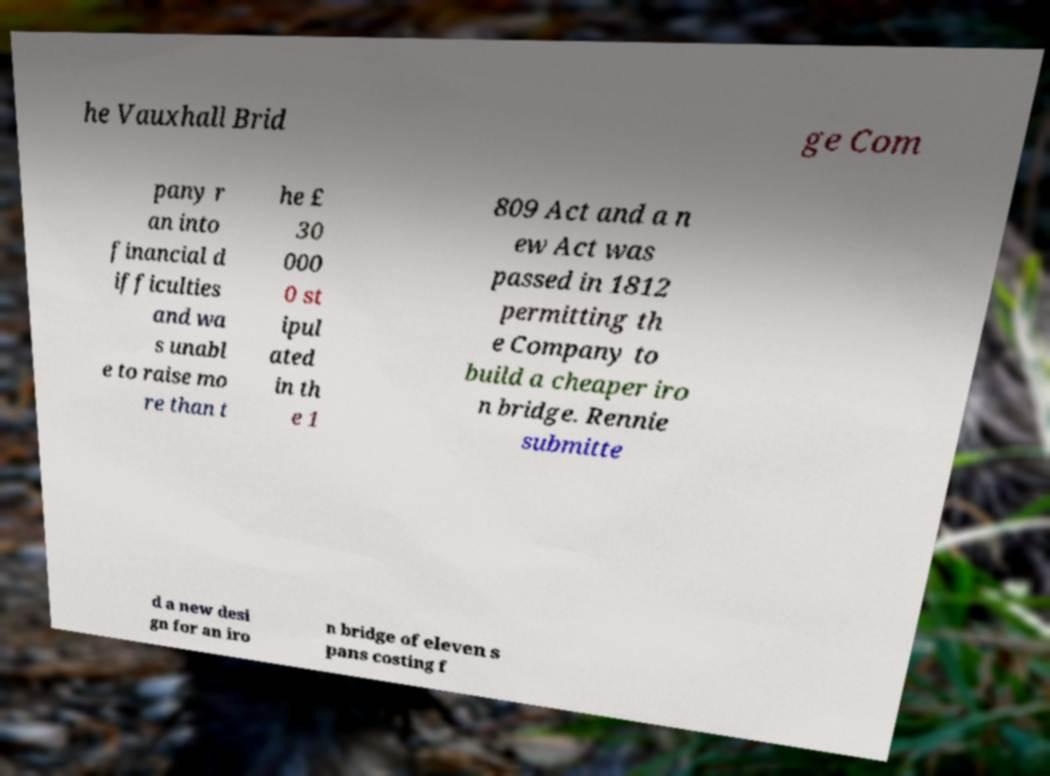Could you assist in decoding the text presented in this image and type it out clearly? he Vauxhall Brid ge Com pany r an into financial d ifficulties and wa s unabl e to raise mo re than t he £ 30 000 0 st ipul ated in th e 1 809 Act and a n ew Act was passed in 1812 permitting th e Company to build a cheaper iro n bridge. Rennie submitte d a new desi gn for an iro n bridge of eleven s pans costing f 